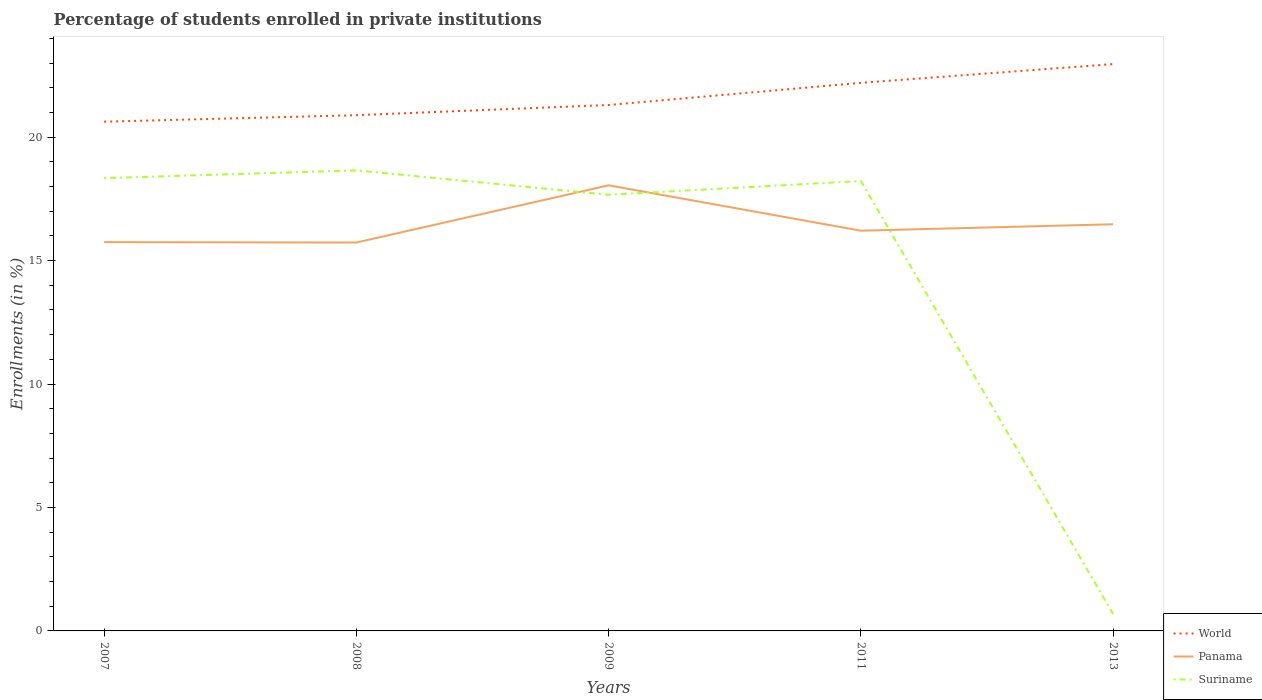How many different coloured lines are there?
Your response must be concise. 3. Does the line corresponding to World intersect with the line corresponding to Suriname?
Offer a terse response. No. Is the number of lines equal to the number of legend labels?
Your response must be concise. Yes. Across all years, what is the maximum percentage of trained teachers in World?
Provide a short and direct response. 20.63. In which year was the percentage of trained teachers in Suriname maximum?
Your answer should be compact. 2013. What is the total percentage of trained teachers in Suriname in the graph?
Give a very brief answer. 0.99. What is the difference between the highest and the second highest percentage of trained teachers in World?
Your answer should be very brief. 2.33. How many lines are there?
Give a very brief answer. 3. How many years are there in the graph?
Provide a short and direct response. 5. Are the values on the major ticks of Y-axis written in scientific E-notation?
Keep it short and to the point. No. Does the graph contain grids?
Make the answer very short. No. Where does the legend appear in the graph?
Give a very brief answer. Bottom right. How many legend labels are there?
Your response must be concise. 3. How are the legend labels stacked?
Make the answer very short. Vertical. What is the title of the graph?
Provide a short and direct response. Percentage of students enrolled in private institutions. Does "Middle East & North Africa (all income levels)" appear as one of the legend labels in the graph?
Offer a very short reply. No. What is the label or title of the Y-axis?
Provide a succinct answer. Enrollments (in %). What is the Enrollments (in %) in World in 2007?
Provide a succinct answer. 20.63. What is the Enrollments (in %) in Panama in 2007?
Your answer should be compact. 15.75. What is the Enrollments (in %) of Suriname in 2007?
Your response must be concise. 18.34. What is the Enrollments (in %) in World in 2008?
Give a very brief answer. 20.89. What is the Enrollments (in %) of Panama in 2008?
Offer a very short reply. 15.73. What is the Enrollments (in %) of Suriname in 2008?
Your answer should be very brief. 18.65. What is the Enrollments (in %) of World in 2009?
Offer a terse response. 21.3. What is the Enrollments (in %) in Panama in 2009?
Provide a short and direct response. 18.05. What is the Enrollments (in %) in Suriname in 2009?
Offer a terse response. 17.67. What is the Enrollments (in %) in World in 2011?
Your answer should be very brief. 22.2. What is the Enrollments (in %) in Panama in 2011?
Ensure brevity in your answer.  16.21. What is the Enrollments (in %) in Suriname in 2011?
Your response must be concise. 18.22. What is the Enrollments (in %) in World in 2013?
Make the answer very short. 22.96. What is the Enrollments (in %) in Panama in 2013?
Ensure brevity in your answer.  16.47. What is the Enrollments (in %) in Suriname in 2013?
Your answer should be compact. 0.68. Across all years, what is the maximum Enrollments (in %) in World?
Offer a terse response. 22.96. Across all years, what is the maximum Enrollments (in %) of Panama?
Offer a very short reply. 18.05. Across all years, what is the maximum Enrollments (in %) of Suriname?
Make the answer very short. 18.65. Across all years, what is the minimum Enrollments (in %) of World?
Your answer should be compact. 20.63. Across all years, what is the minimum Enrollments (in %) in Panama?
Provide a short and direct response. 15.73. Across all years, what is the minimum Enrollments (in %) in Suriname?
Your answer should be very brief. 0.68. What is the total Enrollments (in %) in World in the graph?
Provide a short and direct response. 107.98. What is the total Enrollments (in %) in Panama in the graph?
Your response must be concise. 82.21. What is the total Enrollments (in %) in Suriname in the graph?
Your response must be concise. 73.57. What is the difference between the Enrollments (in %) in World in 2007 and that in 2008?
Offer a very short reply. -0.26. What is the difference between the Enrollments (in %) in Panama in 2007 and that in 2008?
Give a very brief answer. 0.02. What is the difference between the Enrollments (in %) in Suriname in 2007 and that in 2008?
Keep it short and to the point. -0.31. What is the difference between the Enrollments (in %) of World in 2007 and that in 2009?
Make the answer very short. -0.68. What is the difference between the Enrollments (in %) of Panama in 2007 and that in 2009?
Make the answer very short. -2.3. What is the difference between the Enrollments (in %) in Suriname in 2007 and that in 2009?
Keep it short and to the point. 0.67. What is the difference between the Enrollments (in %) in World in 2007 and that in 2011?
Provide a short and direct response. -1.57. What is the difference between the Enrollments (in %) in Panama in 2007 and that in 2011?
Offer a terse response. -0.46. What is the difference between the Enrollments (in %) in Suriname in 2007 and that in 2011?
Ensure brevity in your answer.  0.12. What is the difference between the Enrollments (in %) in World in 2007 and that in 2013?
Provide a succinct answer. -2.33. What is the difference between the Enrollments (in %) in Panama in 2007 and that in 2013?
Offer a terse response. -0.72. What is the difference between the Enrollments (in %) in Suriname in 2007 and that in 2013?
Ensure brevity in your answer.  17.66. What is the difference between the Enrollments (in %) in World in 2008 and that in 2009?
Your response must be concise. -0.41. What is the difference between the Enrollments (in %) of Panama in 2008 and that in 2009?
Your answer should be very brief. -2.32. What is the difference between the Enrollments (in %) in Suriname in 2008 and that in 2009?
Offer a very short reply. 0.99. What is the difference between the Enrollments (in %) in World in 2008 and that in 2011?
Offer a very short reply. -1.31. What is the difference between the Enrollments (in %) in Panama in 2008 and that in 2011?
Keep it short and to the point. -0.48. What is the difference between the Enrollments (in %) in Suriname in 2008 and that in 2011?
Offer a terse response. 0.43. What is the difference between the Enrollments (in %) in World in 2008 and that in 2013?
Offer a terse response. -2.07. What is the difference between the Enrollments (in %) of Panama in 2008 and that in 2013?
Your answer should be compact. -0.74. What is the difference between the Enrollments (in %) in Suriname in 2008 and that in 2013?
Offer a terse response. 17.97. What is the difference between the Enrollments (in %) in World in 2009 and that in 2011?
Provide a succinct answer. -0.9. What is the difference between the Enrollments (in %) in Panama in 2009 and that in 2011?
Your answer should be very brief. 1.84. What is the difference between the Enrollments (in %) in Suriname in 2009 and that in 2011?
Your answer should be very brief. -0.56. What is the difference between the Enrollments (in %) in World in 2009 and that in 2013?
Your answer should be very brief. -1.66. What is the difference between the Enrollments (in %) in Panama in 2009 and that in 2013?
Provide a short and direct response. 1.58. What is the difference between the Enrollments (in %) in Suriname in 2009 and that in 2013?
Your answer should be compact. 16.98. What is the difference between the Enrollments (in %) of World in 2011 and that in 2013?
Your answer should be very brief. -0.76. What is the difference between the Enrollments (in %) of Panama in 2011 and that in 2013?
Offer a very short reply. -0.26. What is the difference between the Enrollments (in %) of Suriname in 2011 and that in 2013?
Give a very brief answer. 17.54. What is the difference between the Enrollments (in %) of World in 2007 and the Enrollments (in %) of Panama in 2008?
Your answer should be very brief. 4.89. What is the difference between the Enrollments (in %) of World in 2007 and the Enrollments (in %) of Suriname in 2008?
Provide a succinct answer. 1.97. What is the difference between the Enrollments (in %) of Panama in 2007 and the Enrollments (in %) of Suriname in 2008?
Keep it short and to the point. -2.91. What is the difference between the Enrollments (in %) of World in 2007 and the Enrollments (in %) of Panama in 2009?
Your answer should be compact. 2.58. What is the difference between the Enrollments (in %) in World in 2007 and the Enrollments (in %) in Suriname in 2009?
Keep it short and to the point. 2.96. What is the difference between the Enrollments (in %) of Panama in 2007 and the Enrollments (in %) of Suriname in 2009?
Offer a very short reply. -1.92. What is the difference between the Enrollments (in %) in World in 2007 and the Enrollments (in %) in Panama in 2011?
Ensure brevity in your answer.  4.42. What is the difference between the Enrollments (in %) of World in 2007 and the Enrollments (in %) of Suriname in 2011?
Offer a very short reply. 2.4. What is the difference between the Enrollments (in %) in Panama in 2007 and the Enrollments (in %) in Suriname in 2011?
Offer a very short reply. -2.48. What is the difference between the Enrollments (in %) in World in 2007 and the Enrollments (in %) in Panama in 2013?
Offer a very short reply. 4.15. What is the difference between the Enrollments (in %) in World in 2007 and the Enrollments (in %) in Suriname in 2013?
Give a very brief answer. 19.94. What is the difference between the Enrollments (in %) of Panama in 2007 and the Enrollments (in %) of Suriname in 2013?
Offer a very short reply. 15.06. What is the difference between the Enrollments (in %) in World in 2008 and the Enrollments (in %) in Panama in 2009?
Keep it short and to the point. 2.84. What is the difference between the Enrollments (in %) of World in 2008 and the Enrollments (in %) of Suriname in 2009?
Offer a terse response. 3.22. What is the difference between the Enrollments (in %) of Panama in 2008 and the Enrollments (in %) of Suriname in 2009?
Provide a short and direct response. -1.93. What is the difference between the Enrollments (in %) in World in 2008 and the Enrollments (in %) in Panama in 2011?
Keep it short and to the point. 4.68. What is the difference between the Enrollments (in %) of World in 2008 and the Enrollments (in %) of Suriname in 2011?
Keep it short and to the point. 2.67. What is the difference between the Enrollments (in %) of Panama in 2008 and the Enrollments (in %) of Suriname in 2011?
Ensure brevity in your answer.  -2.49. What is the difference between the Enrollments (in %) in World in 2008 and the Enrollments (in %) in Panama in 2013?
Offer a terse response. 4.42. What is the difference between the Enrollments (in %) in World in 2008 and the Enrollments (in %) in Suriname in 2013?
Provide a succinct answer. 20.21. What is the difference between the Enrollments (in %) of Panama in 2008 and the Enrollments (in %) of Suriname in 2013?
Your response must be concise. 15.05. What is the difference between the Enrollments (in %) of World in 2009 and the Enrollments (in %) of Panama in 2011?
Ensure brevity in your answer.  5.09. What is the difference between the Enrollments (in %) in World in 2009 and the Enrollments (in %) in Suriname in 2011?
Your answer should be compact. 3.08. What is the difference between the Enrollments (in %) in Panama in 2009 and the Enrollments (in %) in Suriname in 2011?
Your answer should be compact. -0.18. What is the difference between the Enrollments (in %) of World in 2009 and the Enrollments (in %) of Panama in 2013?
Make the answer very short. 4.83. What is the difference between the Enrollments (in %) of World in 2009 and the Enrollments (in %) of Suriname in 2013?
Provide a short and direct response. 20.62. What is the difference between the Enrollments (in %) in Panama in 2009 and the Enrollments (in %) in Suriname in 2013?
Make the answer very short. 17.37. What is the difference between the Enrollments (in %) in World in 2011 and the Enrollments (in %) in Panama in 2013?
Give a very brief answer. 5.73. What is the difference between the Enrollments (in %) of World in 2011 and the Enrollments (in %) of Suriname in 2013?
Give a very brief answer. 21.52. What is the difference between the Enrollments (in %) in Panama in 2011 and the Enrollments (in %) in Suriname in 2013?
Provide a succinct answer. 15.53. What is the average Enrollments (in %) in World per year?
Give a very brief answer. 21.6. What is the average Enrollments (in %) of Panama per year?
Keep it short and to the point. 16.44. What is the average Enrollments (in %) in Suriname per year?
Provide a short and direct response. 14.71. In the year 2007, what is the difference between the Enrollments (in %) in World and Enrollments (in %) in Panama?
Provide a succinct answer. 4.88. In the year 2007, what is the difference between the Enrollments (in %) of World and Enrollments (in %) of Suriname?
Your response must be concise. 2.29. In the year 2007, what is the difference between the Enrollments (in %) of Panama and Enrollments (in %) of Suriname?
Make the answer very short. -2.59. In the year 2008, what is the difference between the Enrollments (in %) of World and Enrollments (in %) of Panama?
Your answer should be compact. 5.16. In the year 2008, what is the difference between the Enrollments (in %) in World and Enrollments (in %) in Suriname?
Your response must be concise. 2.24. In the year 2008, what is the difference between the Enrollments (in %) in Panama and Enrollments (in %) in Suriname?
Give a very brief answer. -2.92. In the year 2009, what is the difference between the Enrollments (in %) in World and Enrollments (in %) in Panama?
Offer a terse response. 3.25. In the year 2009, what is the difference between the Enrollments (in %) of World and Enrollments (in %) of Suriname?
Your answer should be compact. 3.64. In the year 2009, what is the difference between the Enrollments (in %) in Panama and Enrollments (in %) in Suriname?
Your response must be concise. 0.38. In the year 2011, what is the difference between the Enrollments (in %) of World and Enrollments (in %) of Panama?
Ensure brevity in your answer.  5.99. In the year 2011, what is the difference between the Enrollments (in %) in World and Enrollments (in %) in Suriname?
Keep it short and to the point. 3.98. In the year 2011, what is the difference between the Enrollments (in %) of Panama and Enrollments (in %) of Suriname?
Keep it short and to the point. -2.01. In the year 2013, what is the difference between the Enrollments (in %) of World and Enrollments (in %) of Panama?
Give a very brief answer. 6.49. In the year 2013, what is the difference between the Enrollments (in %) in World and Enrollments (in %) in Suriname?
Give a very brief answer. 22.28. In the year 2013, what is the difference between the Enrollments (in %) in Panama and Enrollments (in %) in Suriname?
Ensure brevity in your answer.  15.79. What is the ratio of the Enrollments (in %) of World in 2007 to that in 2008?
Ensure brevity in your answer.  0.99. What is the ratio of the Enrollments (in %) of Suriname in 2007 to that in 2008?
Your answer should be very brief. 0.98. What is the ratio of the Enrollments (in %) of World in 2007 to that in 2009?
Your answer should be compact. 0.97. What is the ratio of the Enrollments (in %) in Panama in 2007 to that in 2009?
Make the answer very short. 0.87. What is the ratio of the Enrollments (in %) of Suriname in 2007 to that in 2009?
Offer a very short reply. 1.04. What is the ratio of the Enrollments (in %) in World in 2007 to that in 2011?
Offer a very short reply. 0.93. What is the ratio of the Enrollments (in %) in Panama in 2007 to that in 2011?
Ensure brevity in your answer.  0.97. What is the ratio of the Enrollments (in %) of Suriname in 2007 to that in 2011?
Provide a succinct answer. 1.01. What is the ratio of the Enrollments (in %) of World in 2007 to that in 2013?
Offer a terse response. 0.9. What is the ratio of the Enrollments (in %) of Panama in 2007 to that in 2013?
Your response must be concise. 0.96. What is the ratio of the Enrollments (in %) of Suriname in 2007 to that in 2013?
Your answer should be very brief. 26.84. What is the ratio of the Enrollments (in %) in World in 2008 to that in 2009?
Your response must be concise. 0.98. What is the ratio of the Enrollments (in %) of Panama in 2008 to that in 2009?
Offer a terse response. 0.87. What is the ratio of the Enrollments (in %) of Suriname in 2008 to that in 2009?
Ensure brevity in your answer.  1.06. What is the ratio of the Enrollments (in %) in World in 2008 to that in 2011?
Your answer should be compact. 0.94. What is the ratio of the Enrollments (in %) in Panama in 2008 to that in 2011?
Keep it short and to the point. 0.97. What is the ratio of the Enrollments (in %) of Suriname in 2008 to that in 2011?
Ensure brevity in your answer.  1.02. What is the ratio of the Enrollments (in %) in World in 2008 to that in 2013?
Offer a terse response. 0.91. What is the ratio of the Enrollments (in %) of Panama in 2008 to that in 2013?
Ensure brevity in your answer.  0.96. What is the ratio of the Enrollments (in %) in Suriname in 2008 to that in 2013?
Ensure brevity in your answer.  27.3. What is the ratio of the Enrollments (in %) in World in 2009 to that in 2011?
Offer a very short reply. 0.96. What is the ratio of the Enrollments (in %) in Panama in 2009 to that in 2011?
Ensure brevity in your answer.  1.11. What is the ratio of the Enrollments (in %) of Suriname in 2009 to that in 2011?
Provide a short and direct response. 0.97. What is the ratio of the Enrollments (in %) in World in 2009 to that in 2013?
Offer a very short reply. 0.93. What is the ratio of the Enrollments (in %) of Panama in 2009 to that in 2013?
Ensure brevity in your answer.  1.1. What is the ratio of the Enrollments (in %) in Suriname in 2009 to that in 2013?
Give a very brief answer. 25.85. What is the ratio of the Enrollments (in %) of World in 2011 to that in 2013?
Ensure brevity in your answer.  0.97. What is the ratio of the Enrollments (in %) of Panama in 2011 to that in 2013?
Make the answer very short. 0.98. What is the ratio of the Enrollments (in %) in Suriname in 2011 to that in 2013?
Provide a succinct answer. 26.67. What is the difference between the highest and the second highest Enrollments (in %) in World?
Keep it short and to the point. 0.76. What is the difference between the highest and the second highest Enrollments (in %) in Panama?
Keep it short and to the point. 1.58. What is the difference between the highest and the second highest Enrollments (in %) of Suriname?
Your response must be concise. 0.31. What is the difference between the highest and the lowest Enrollments (in %) in World?
Your answer should be compact. 2.33. What is the difference between the highest and the lowest Enrollments (in %) in Panama?
Offer a terse response. 2.32. What is the difference between the highest and the lowest Enrollments (in %) in Suriname?
Give a very brief answer. 17.97. 